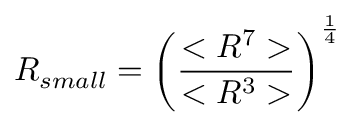<formula> <loc_0><loc_0><loc_500><loc_500>R _ { s m a l l } = \left ( \frac { < R ^ { 7 } > } { < R ^ { 3 } > } \right ) ^ { \frac { 1 } { 4 } }</formula> 